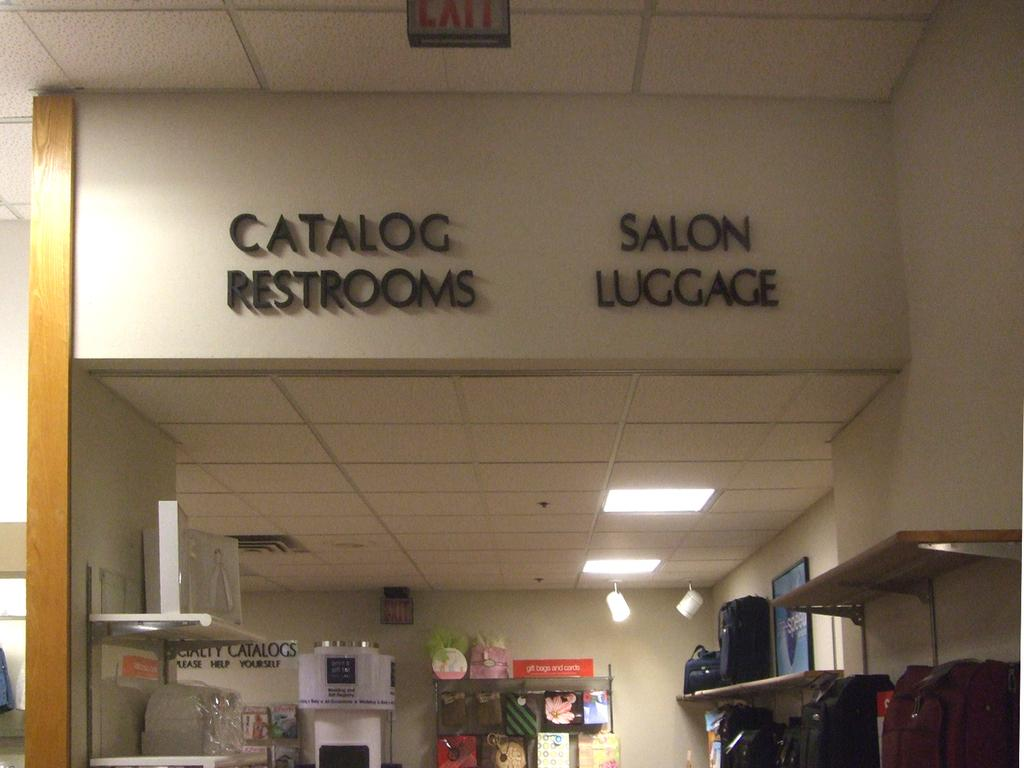Provide a one-sentence caption for the provided image. Catalog restrooms and salon luggage inside a building. 